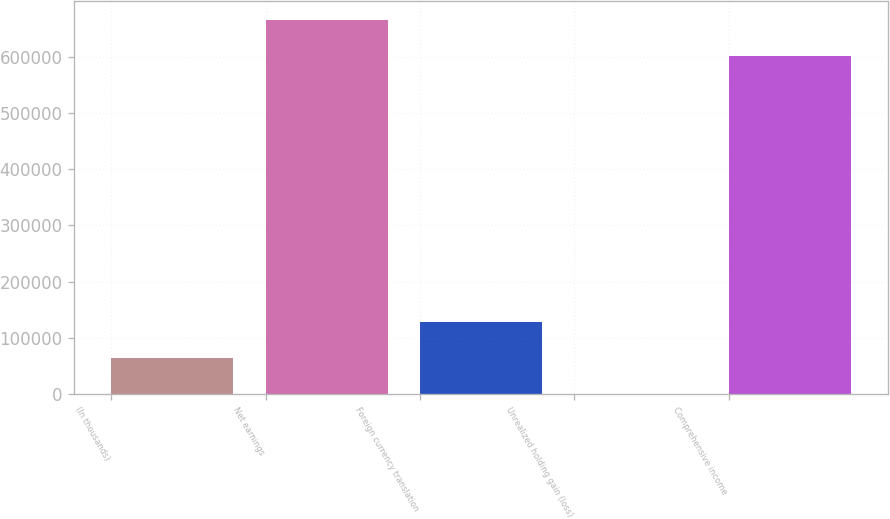Convert chart. <chart><loc_0><loc_0><loc_500><loc_500><bar_chart><fcel>(In thousands)<fcel>Net earnings<fcel>Foreign currency translation<fcel>Unrealized holding gain (loss)<fcel>Comprehensive income<nl><fcel>63702.4<fcel>666315<fcel>127345<fcel>60<fcel>602673<nl></chart> 